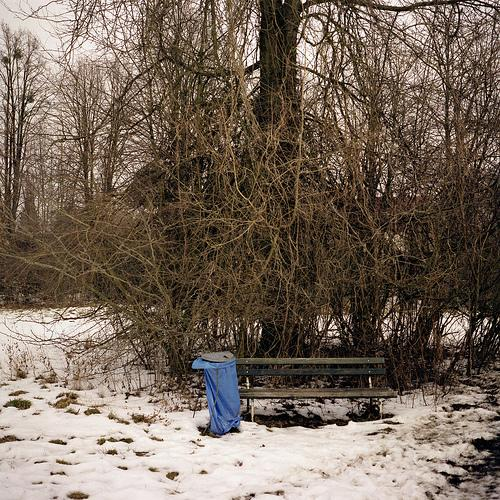Describe the trash can and its surroundings in the image. The trash can features a chain, lid, and a blue bag inside, and it is located in the snow next to a wooden bench and bare trees. Provide a detailed description of the wooden bench in the image. The wooden bench is a dark brown, old-looking structure in the snow, featuring a sitting area, backing, legs, and is partially covered with a towel. Write a brief summary of the objects and environment in the image. The image contains a wooden bench surrounded by snow, bare trees, a blue trash bag, and a trash can, creating a serene and cold winter environment. Identify the dominant object in the image and describe its location. A wooden bench is positioned in front of branches, covered in white snow and surrounded by a blue trash bag, bare trees, and a trash can. List all the visible objects in the image. Wooden bench, blue trash bag, trash can, bare trees, branches, snow, towel, rocks, grass, and tree trunks. Detail the tree and branch objects found in the image. The trees are bare, tall, and thin with no leaves, featuring spindly branches, large trunks, and some patches of green moss. Describe the overall scene captured in the image. The image depicts a snow-covered park with a wooden bench, blue trash bag, bare trees, and a trash can, all set against a cloudy gray sky. Mention the three main objects in the image and where they are located. The main objects are the wooden bench located in front of branches, the blue trash bag to the left of the bench, and the trash can with a blue bag in the snow. Provide a creative description of the environment captured in the image. A tranquil, snow-kissed park scene unfolds, showcasing an old wooden bench, a trash can carrying a blue bag, and the graceful dance of bare tree branches against a cloudy sky. Describe the weather conditions in the image. The weather appears to be cold and snowy, with a pale, cloudy gray sky and snow covering the ground and objects. 